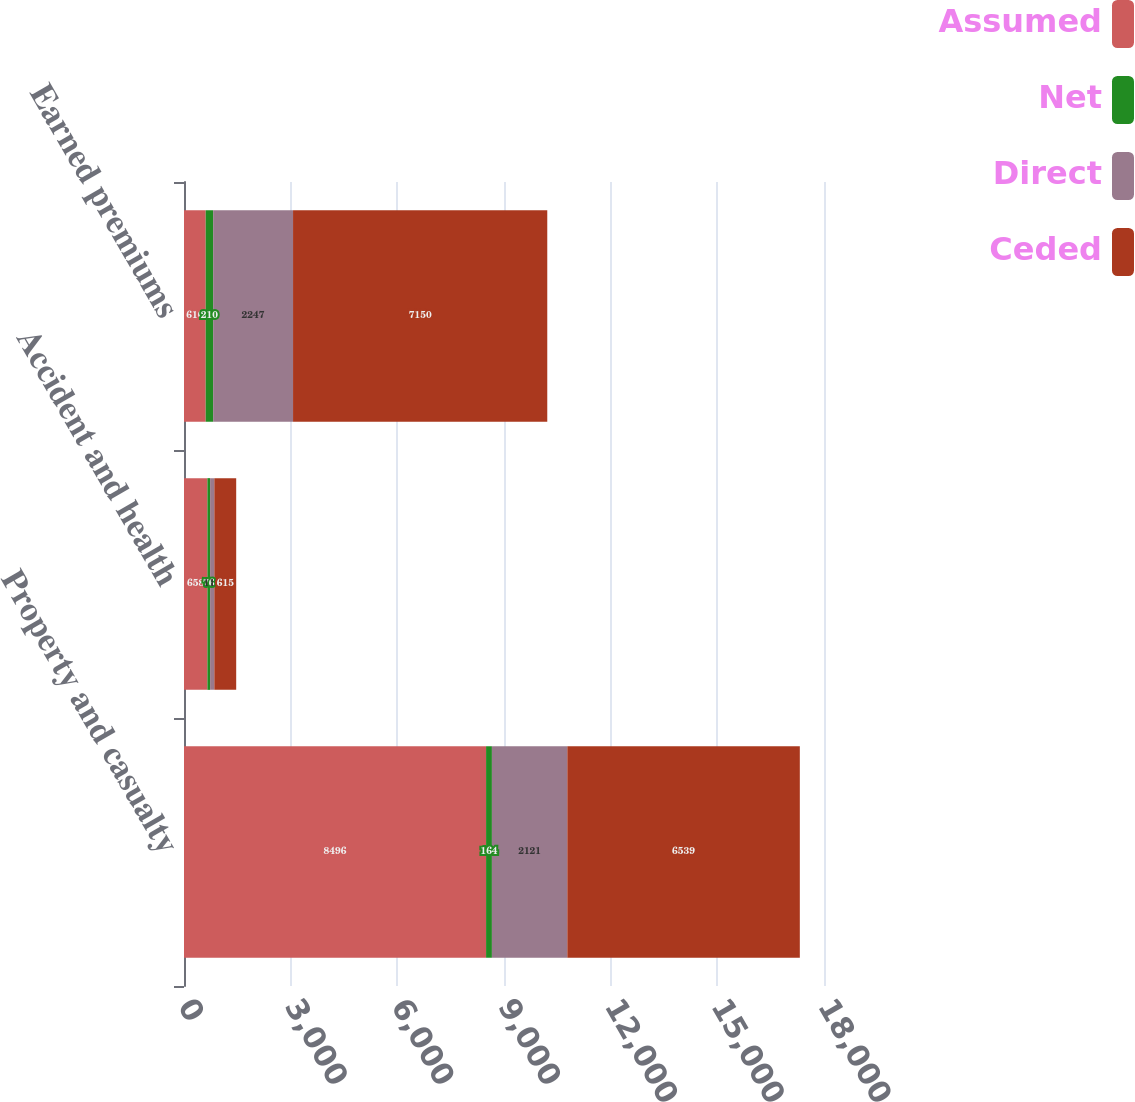<chart> <loc_0><loc_0><loc_500><loc_500><stacked_bar_chart><ecel><fcel>Property and casualty<fcel>Accident and health<fcel>Earned premiums<nl><fcel>Assumed<fcel>8496<fcel>658<fcel>610<nl><fcel>Net<fcel>164<fcel>76<fcel>210<nl><fcel>Direct<fcel>2121<fcel>119<fcel>2247<nl><fcel>Ceded<fcel>6539<fcel>615<fcel>7150<nl></chart> 